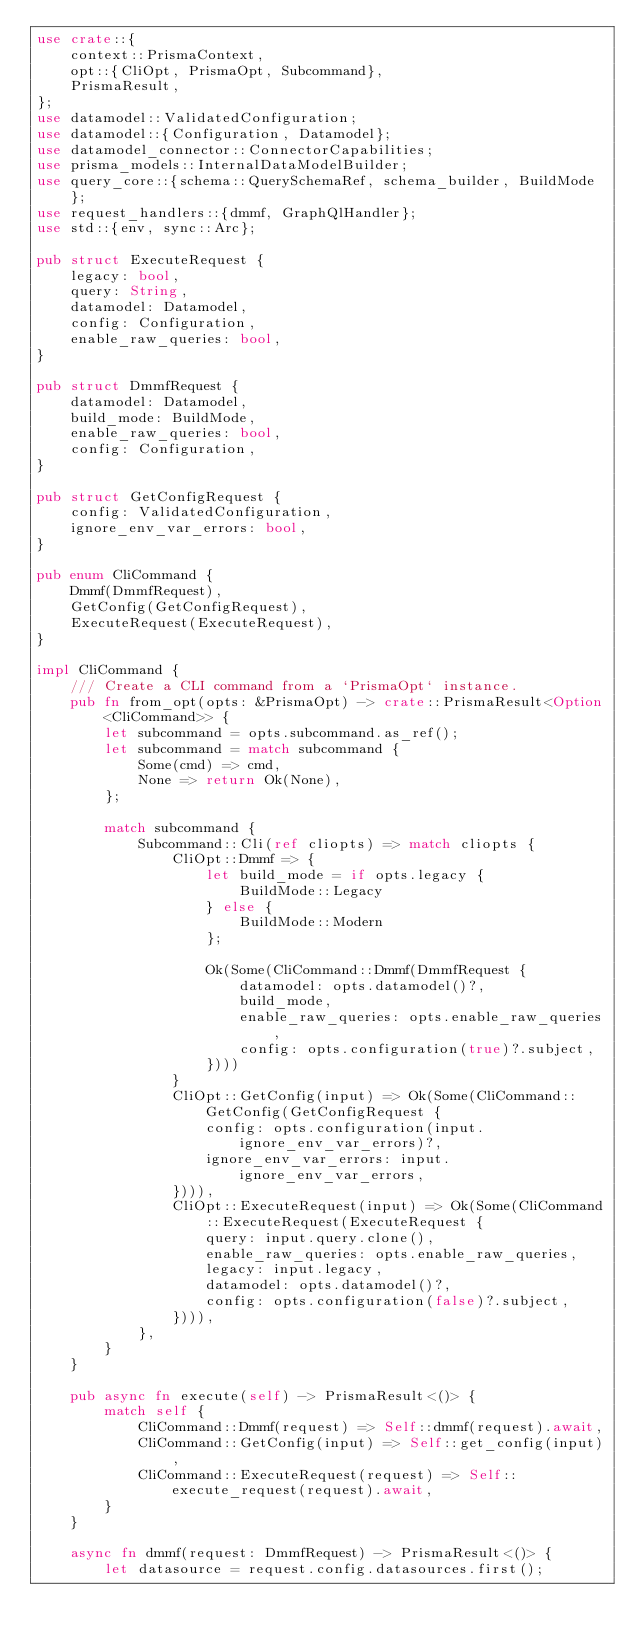Convert code to text. <code><loc_0><loc_0><loc_500><loc_500><_Rust_>use crate::{
    context::PrismaContext,
    opt::{CliOpt, PrismaOpt, Subcommand},
    PrismaResult,
};
use datamodel::ValidatedConfiguration;
use datamodel::{Configuration, Datamodel};
use datamodel_connector::ConnectorCapabilities;
use prisma_models::InternalDataModelBuilder;
use query_core::{schema::QuerySchemaRef, schema_builder, BuildMode};
use request_handlers::{dmmf, GraphQlHandler};
use std::{env, sync::Arc};

pub struct ExecuteRequest {
    legacy: bool,
    query: String,
    datamodel: Datamodel,
    config: Configuration,
    enable_raw_queries: bool,
}

pub struct DmmfRequest {
    datamodel: Datamodel,
    build_mode: BuildMode,
    enable_raw_queries: bool,
    config: Configuration,
}

pub struct GetConfigRequest {
    config: ValidatedConfiguration,
    ignore_env_var_errors: bool,
}

pub enum CliCommand {
    Dmmf(DmmfRequest),
    GetConfig(GetConfigRequest),
    ExecuteRequest(ExecuteRequest),
}

impl CliCommand {
    /// Create a CLI command from a `PrismaOpt` instance.
    pub fn from_opt(opts: &PrismaOpt) -> crate::PrismaResult<Option<CliCommand>> {
        let subcommand = opts.subcommand.as_ref();
        let subcommand = match subcommand {
            Some(cmd) => cmd,
            None => return Ok(None),
        };

        match subcommand {
            Subcommand::Cli(ref cliopts) => match cliopts {
                CliOpt::Dmmf => {
                    let build_mode = if opts.legacy {
                        BuildMode::Legacy
                    } else {
                        BuildMode::Modern
                    };

                    Ok(Some(CliCommand::Dmmf(DmmfRequest {
                        datamodel: opts.datamodel()?,
                        build_mode,
                        enable_raw_queries: opts.enable_raw_queries,
                        config: opts.configuration(true)?.subject,
                    })))
                }
                CliOpt::GetConfig(input) => Ok(Some(CliCommand::GetConfig(GetConfigRequest {
                    config: opts.configuration(input.ignore_env_var_errors)?,
                    ignore_env_var_errors: input.ignore_env_var_errors,
                }))),
                CliOpt::ExecuteRequest(input) => Ok(Some(CliCommand::ExecuteRequest(ExecuteRequest {
                    query: input.query.clone(),
                    enable_raw_queries: opts.enable_raw_queries,
                    legacy: input.legacy,
                    datamodel: opts.datamodel()?,
                    config: opts.configuration(false)?.subject,
                }))),
            },
        }
    }

    pub async fn execute(self) -> PrismaResult<()> {
        match self {
            CliCommand::Dmmf(request) => Self::dmmf(request).await,
            CliCommand::GetConfig(input) => Self::get_config(input),
            CliCommand::ExecuteRequest(request) => Self::execute_request(request).await,
        }
    }

    async fn dmmf(request: DmmfRequest) -> PrismaResult<()> {
        let datasource = request.config.datasources.first();</code> 